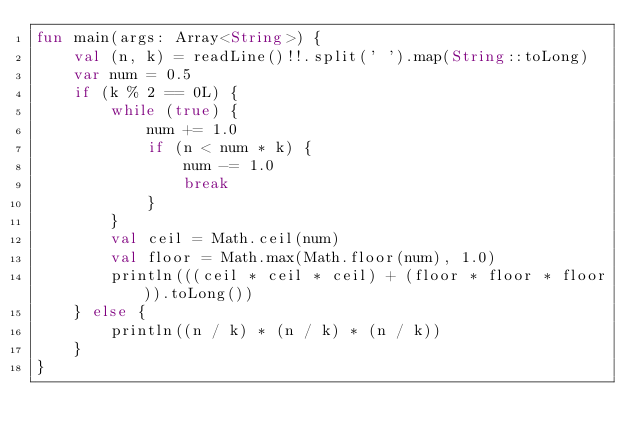<code> <loc_0><loc_0><loc_500><loc_500><_Kotlin_>fun main(args: Array<String>) {
    val (n, k) = readLine()!!.split(' ').map(String::toLong)
    var num = 0.5
    if (k % 2 == 0L) {
        while (true) {
            num += 1.0
            if (n < num * k) {
                num -= 1.0
                break
            }
        }
        val ceil = Math.ceil(num)
        val floor = Math.max(Math.floor(num), 1.0)
        println(((ceil * ceil * ceil) + (floor * floor * floor)).toLong())
    } else {
        println((n / k) * (n / k) * (n / k))
    }
}</code> 